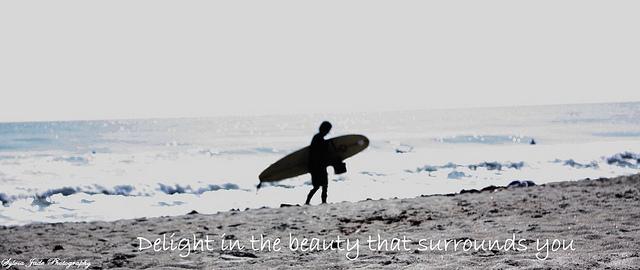What does this photo encourage a person to delight in?
Give a very brief answer. Beauty that surrounds you. Is the image in black and white?
Write a very short answer. No. Can you see the sun?
Concise answer only. No. 